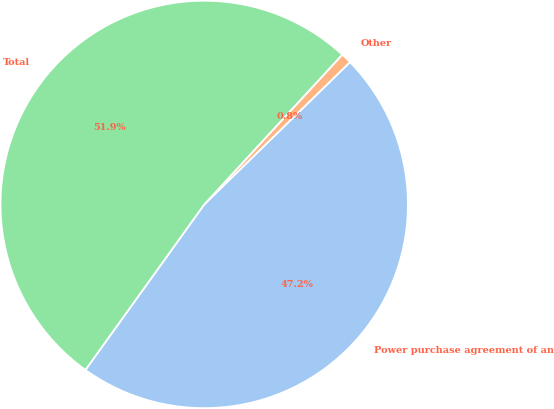Convert chart to OTSL. <chart><loc_0><loc_0><loc_500><loc_500><pie_chart><fcel>Power purchase agreement of an<fcel>Other<fcel>Total<nl><fcel>47.22%<fcel>0.84%<fcel>51.94%<nl></chart> 